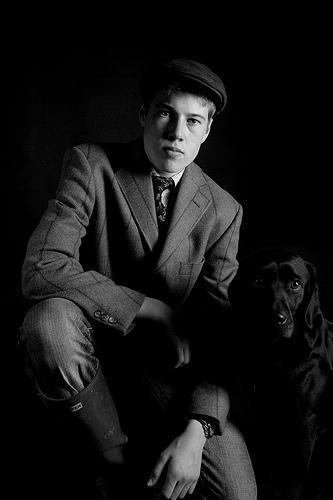How many buttons are on the man's sleeve?
Give a very brief answer. 3. 